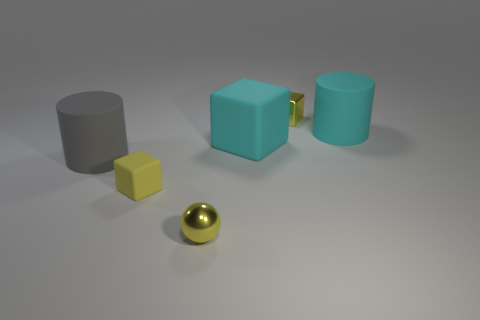Add 2 big gray cylinders. How many objects exist? 8 Subtract all cylinders. How many objects are left? 4 Subtract all gray cylinders. How many cylinders are left? 1 Subtract all yellow cubes. How many cubes are left? 1 Subtract 2 blocks. How many blocks are left? 1 Subtract all brown spheres. Subtract all green cylinders. How many spheres are left? 1 Subtract all green blocks. How many gray cylinders are left? 1 Subtract all brown shiny spheres. Subtract all small yellow shiny blocks. How many objects are left? 5 Add 2 cyan matte cylinders. How many cyan matte cylinders are left? 3 Add 6 tiny purple matte spheres. How many tiny purple matte spheres exist? 6 